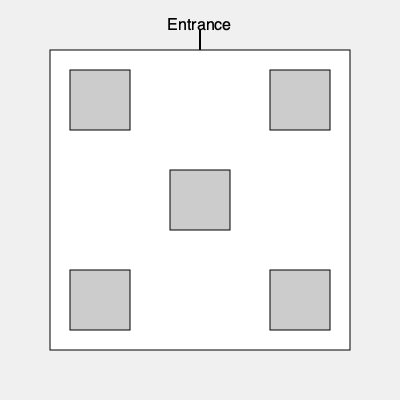Given the restaurant floor plan above, if you were to rotate the layout 90 degrees clockwise, which table would be closest to the entrance? To solve this problem, we need to visualize the rotation of the floor plan:

1. Currently, the entrance is at the top of the diagram.
2. A 90-degree clockwise rotation would move the entrance to the right side of the diagram.
3. After rotation, the tables' positions relative to each other remain the same, but their positions relative to the entrance change.
4. The table that was in the top-right corner before rotation will now be in the bottom-right corner.
5. The table that was in the top-left corner before rotation will now be in the top-right corner, closest to the new position of the entrance.

Therefore, after a 90-degree clockwise rotation, the table that was originally in the top-left corner of the restaurant would be closest to the entrance.
Answer: Top-left table 